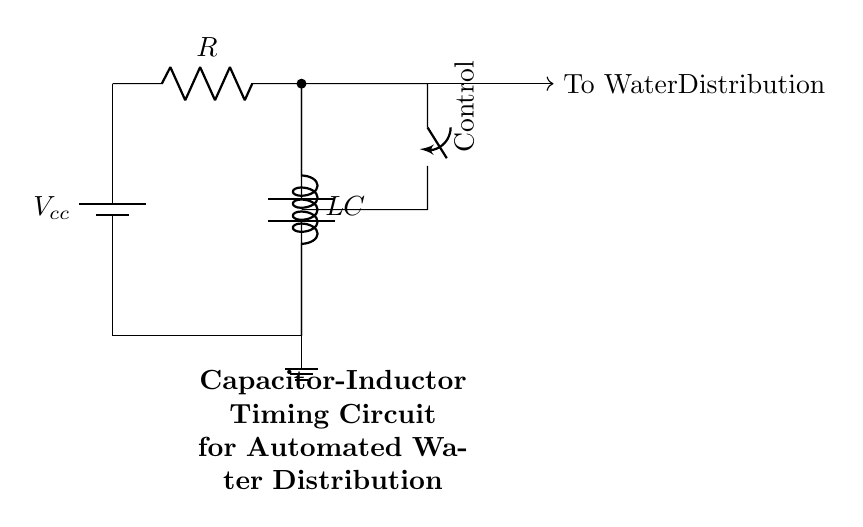What is the voltage source in this circuit? The voltage source in the circuit is labeled as Vcc. It is positioned at the top left of the circuit diagram, denoting the power supply providing voltage to the circuit.
Answer: Vcc What components are used in this circuit? The components used in this circuit include a resistor, an inductor, a capacitor, and a switch. Each component is distinctly labeled in the circuit diagram, indicating their respective identities.
Answer: Resistor, Inductor, Capacitor, Switch What is the role of the switch in the circuit? The switch serves as a control element that can open or close the circuit path. This allows or interrupts the current flow from the voltage source to the inductor and capacitor setup, thus influencing the timing sequence for water distribution.
Answer: Control What is the configuration of the inductor and capacitor in this circuit? The inductor and capacitor are configured in parallel with each other, as illustrated by both components being connected to the same two nodes, allowing them to share voltage while individually affecting the current.
Answer: Parallel How does the timing function occur in this circuit? The timing function occurs due to the interaction between the resistor, inductor, and capacitor. As the capacitor charges and discharges through the inductor and resistor, it creates a timing cycle, determining how long the water distribution system remains active or inactive.
Answer: RC timing circuit What might happen if the resistor value is increased? If the resistor value is increased, it will reduce the overall current flowing through the circuit, leading to a longer charging time for the capacitor. This means that the timing of the water distribution system will be extended, resulting in less frequent activation.
Answer: Longer timing What is the intended output of this circuit? The intended output of this circuit is to control the water distribution system automatically based on the timing set by the capacitor and inductor's charge and discharge cycles, allowing effective water resource management in crop fields.
Answer: To Water Distribution 